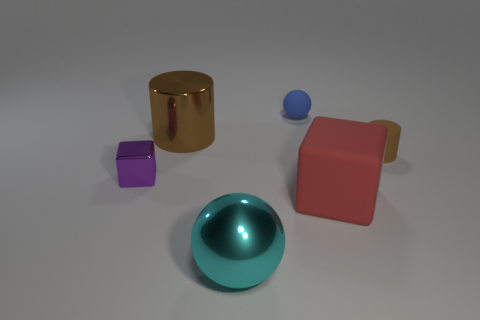There is a small object behind the rubber cylinder; what color is it?
Ensure brevity in your answer.  Blue. There is a big rubber cube; does it have the same color as the big shiny object that is in front of the small brown object?
Ensure brevity in your answer.  No. Is the number of large purple metal balls less than the number of big metal balls?
Offer a terse response. Yes. Do the matte thing in front of the brown matte thing and the tiny metal block have the same color?
Offer a terse response. No. What number of cubes are the same size as the cyan ball?
Ensure brevity in your answer.  1. Is there a metallic cylinder of the same color as the small metallic block?
Offer a very short reply. No. Does the cyan thing have the same material as the blue object?
Offer a very short reply. No. What number of tiny purple objects are the same shape as the large red object?
Make the answer very short. 1. There is a big red thing that is made of the same material as the small cylinder; what shape is it?
Your answer should be very brief. Cube. There is a sphere right of the ball in front of the big brown metallic cylinder; what is its color?
Your response must be concise. Blue. 